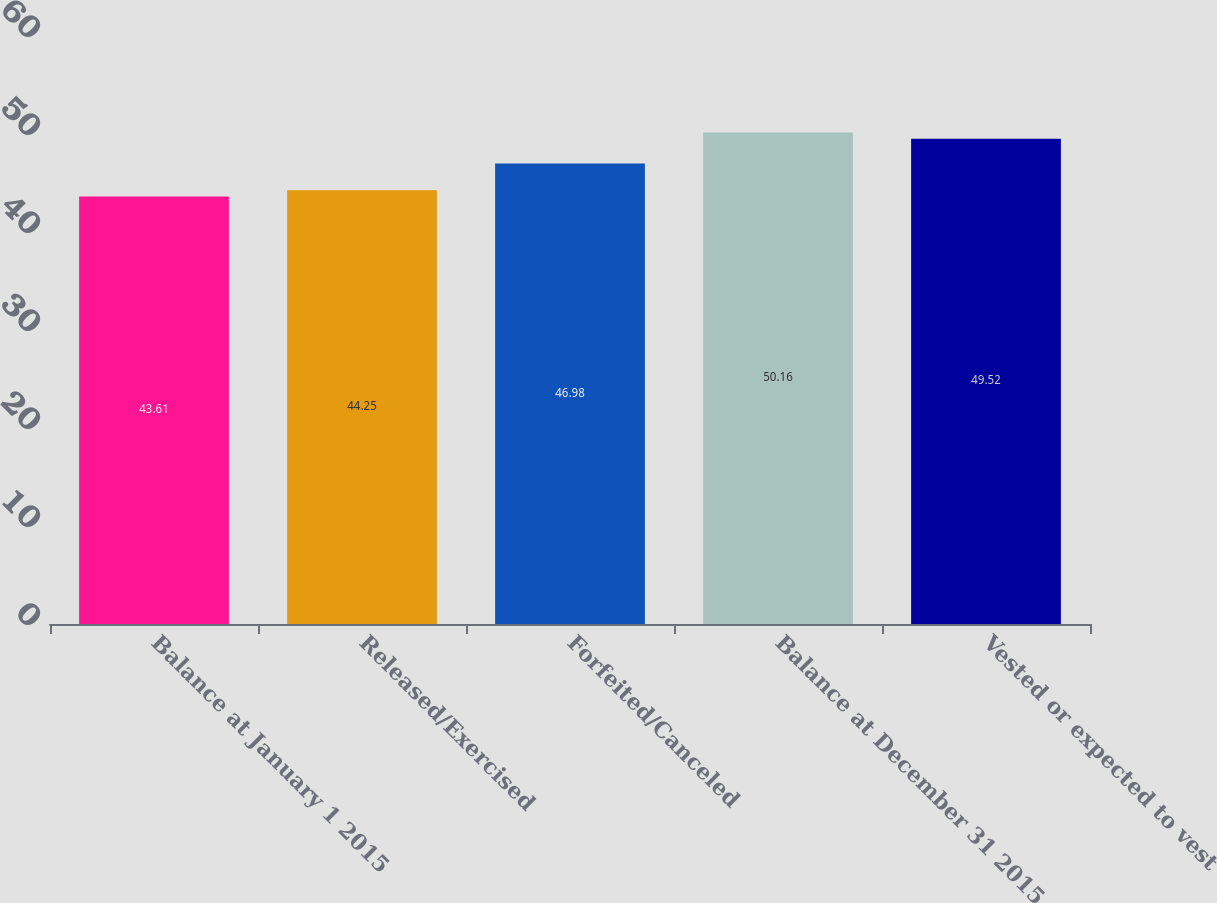Convert chart. <chart><loc_0><loc_0><loc_500><loc_500><bar_chart><fcel>Balance at January 1 2015<fcel>Released/Exercised<fcel>Forfeited/Canceled<fcel>Balance at December 31 2015<fcel>Vested or expected to vest<nl><fcel>43.61<fcel>44.25<fcel>46.98<fcel>50.16<fcel>49.52<nl></chart> 